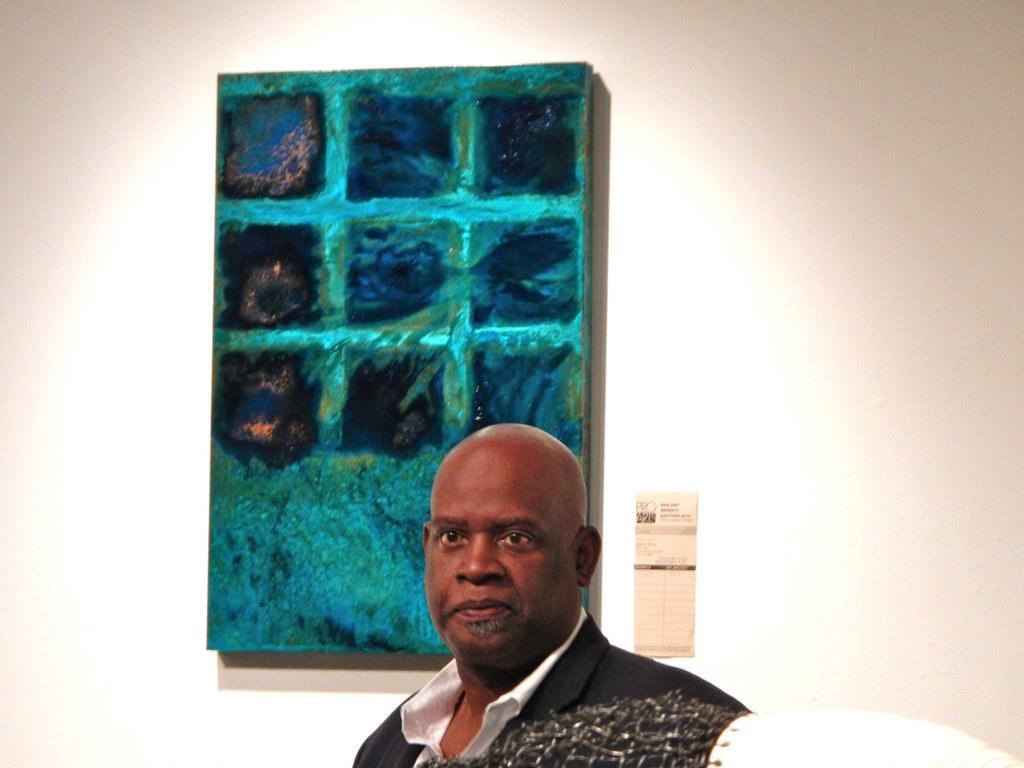Could you give a brief overview of what you see in this image? Here in this picture we can see a man standing over a place and behind him on the wall we can see a painting present. 